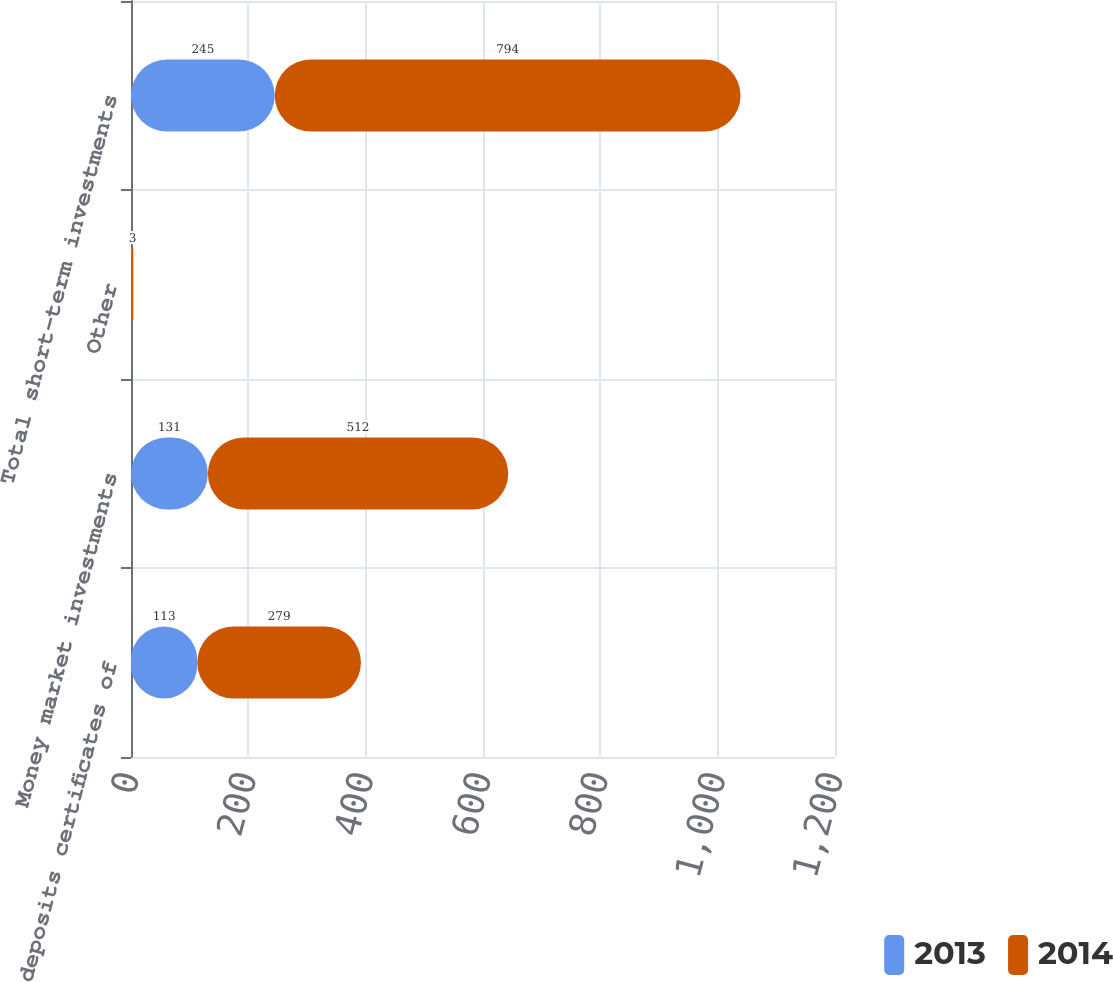Convert chart. <chart><loc_0><loc_0><loc_500><loc_500><stacked_bar_chart><ecel><fcel>Time deposits certificates of<fcel>Money market investments<fcel>Other<fcel>Total short-term investments<nl><fcel>2013<fcel>113<fcel>131<fcel>1<fcel>245<nl><fcel>2014<fcel>279<fcel>512<fcel>3<fcel>794<nl></chart> 